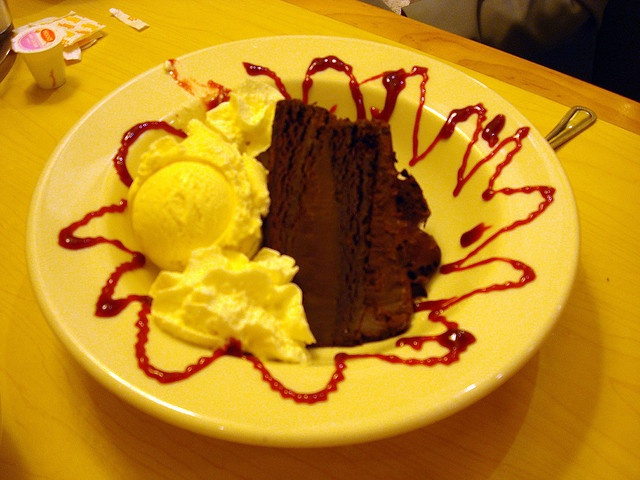Describe the objects in this image and their specific colors. I can see dining table in orange, gold, maroon, and olive tones, bowl in orange, gold, and maroon tones, cake in orange, maroon, black, gold, and olive tones, cup in orange, olive, and tan tones, and spoon in orange, olive, and maroon tones in this image. 